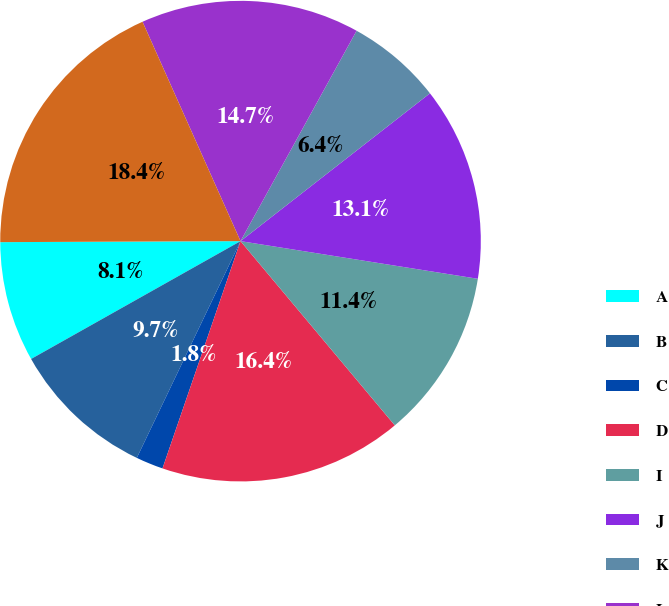<chart> <loc_0><loc_0><loc_500><loc_500><pie_chart><fcel>A<fcel>B<fcel>C<fcel>D<fcel>I<fcel>J<fcel>K<fcel>L<fcel>M 1<nl><fcel>8.09%<fcel>9.74%<fcel>1.84%<fcel>16.36%<fcel>11.4%<fcel>13.05%<fcel>6.43%<fcel>14.71%<fcel>18.38%<nl></chart> 